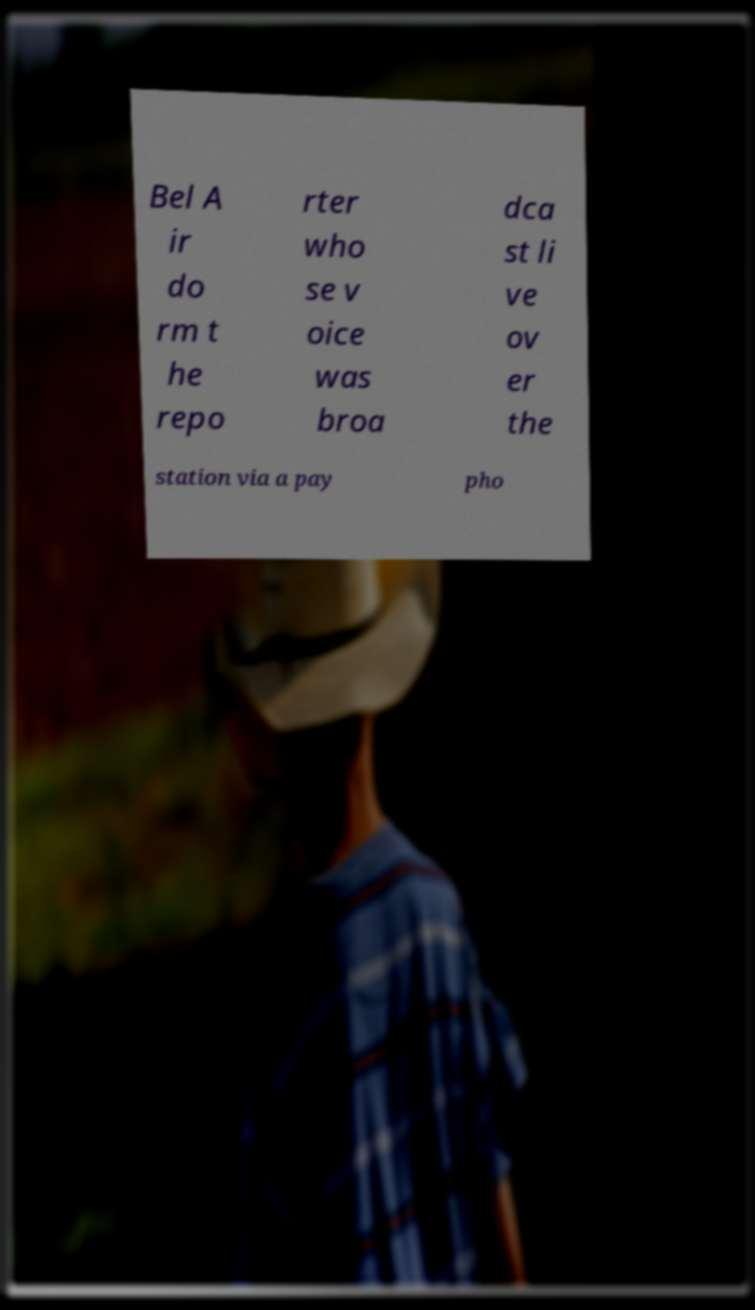Please read and relay the text visible in this image. What does it say? Bel A ir do rm t he repo rter who se v oice was broa dca st li ve ov er the station via a pay pho 